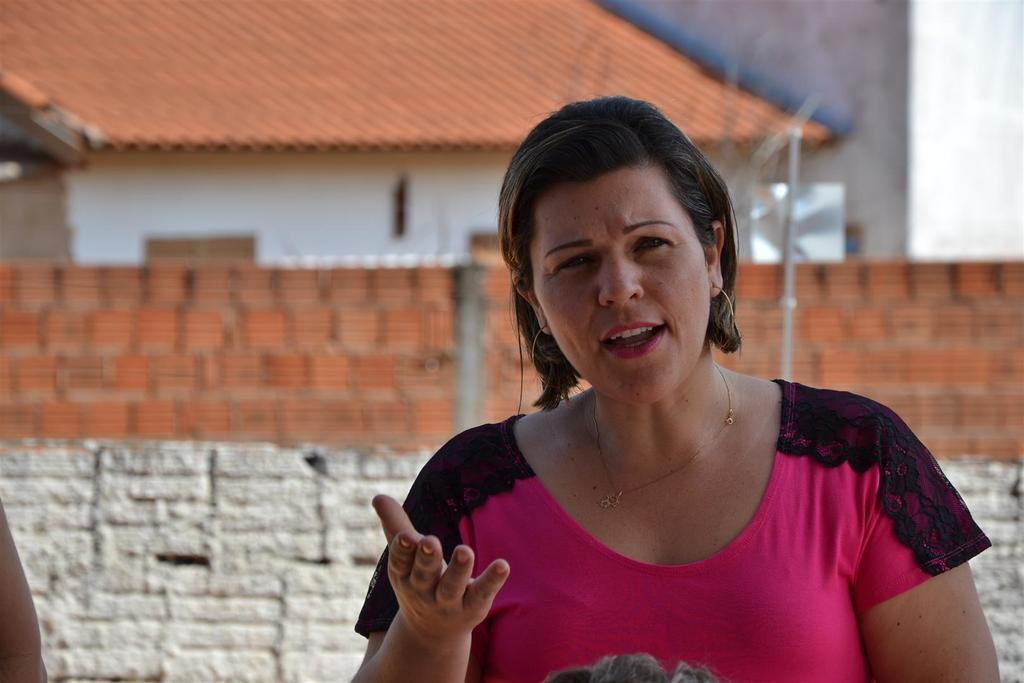Who is the main subject in the foreground of the image? There is a woman in the foreground of the image. What is the woman wearing in the image? The woman is wearing a pink T-shirt. What can be seen in the background of the image? There are walls and a house in the background of the image. What object is visible behind the woman? There appears to be a pole behind the woman. How many men are sitting at the desk in the image? There is no desk or men present in the image. What color is the foot of the woman in the image? There is no foot visible in the image; only the woman's upper body and a pole behind her are shown. 